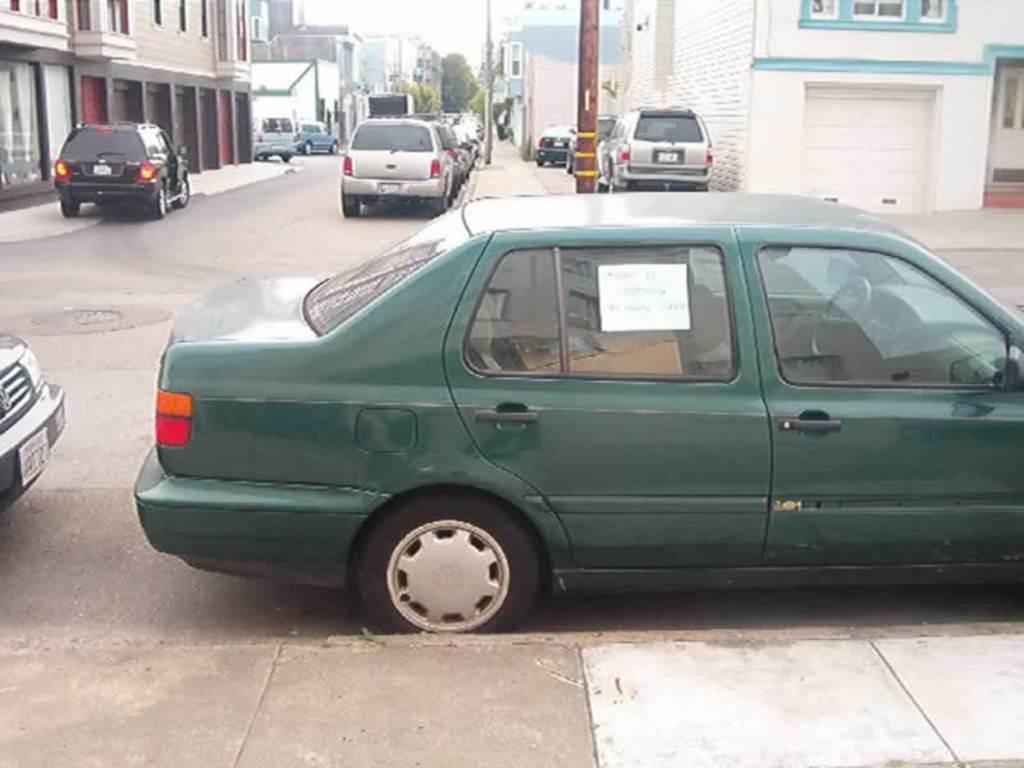Describe this image in one or two sentences. In this picture I can observe some cars parked on either sides of the road. I can observe green, black and silver color cars. On the right side I can observe a pole. In the background there are buildings and trees. 